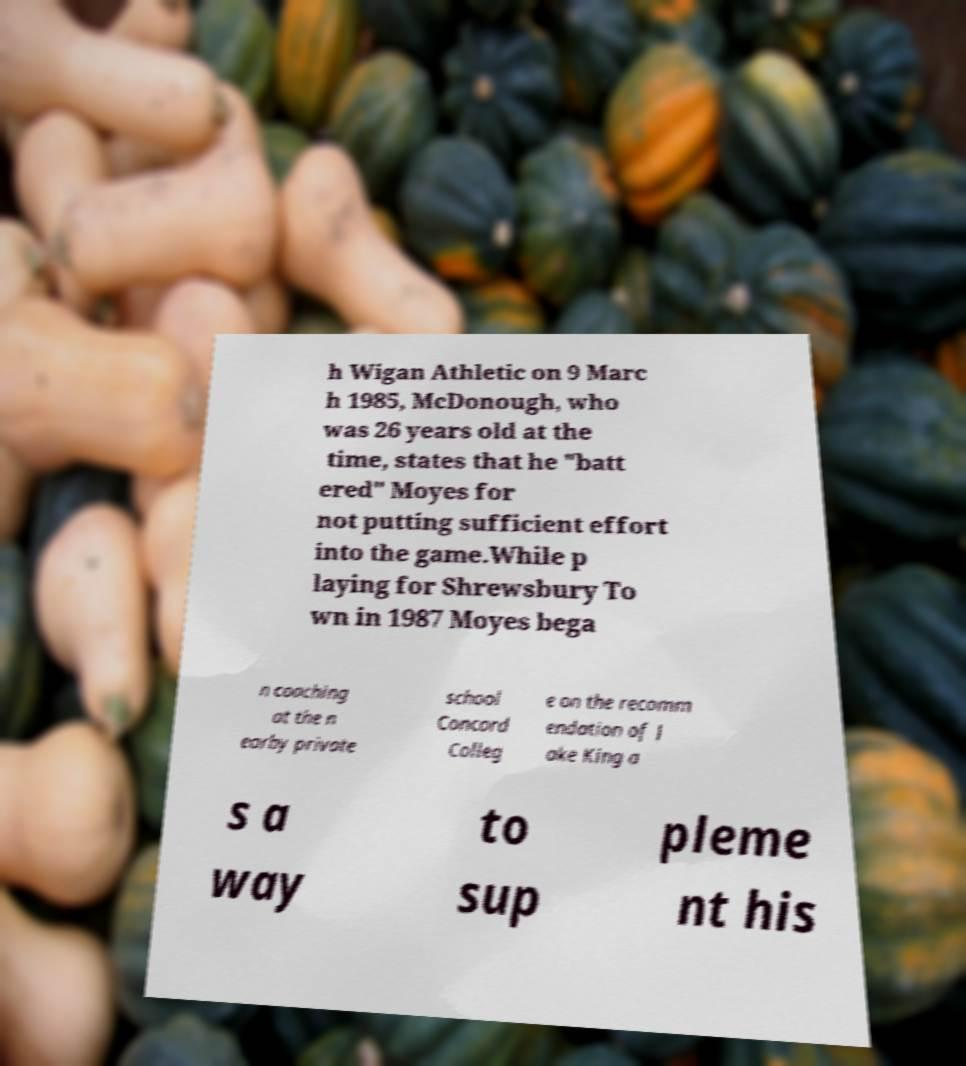Could you assist in decoding the text presented in this image and type it out clearly? h Wigan Athletic on 9 Marc h 1985, McDonough, who was 26 years old at the time, states that he "batt ered" Moyes for not putting sufficient effort into the game.While p laying for Shrewsbury To wn in 1987 Moyes bega n coaching at the n earby private school Concord Colleg e on the recomm endation of J ake King a s a way to sup pleme nt his 